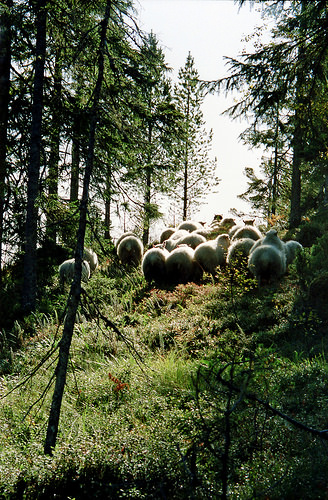<image>
Can you confirm if the sheeps is in the jungle? Yes. The sheeps is contained within or inside the jungle, showing a containment relationship. Where is the sheep in relation to the ground? Is it above the ground? No. The sheep is not positioned above the ground. The vertical arrangement shows a different relationship. 